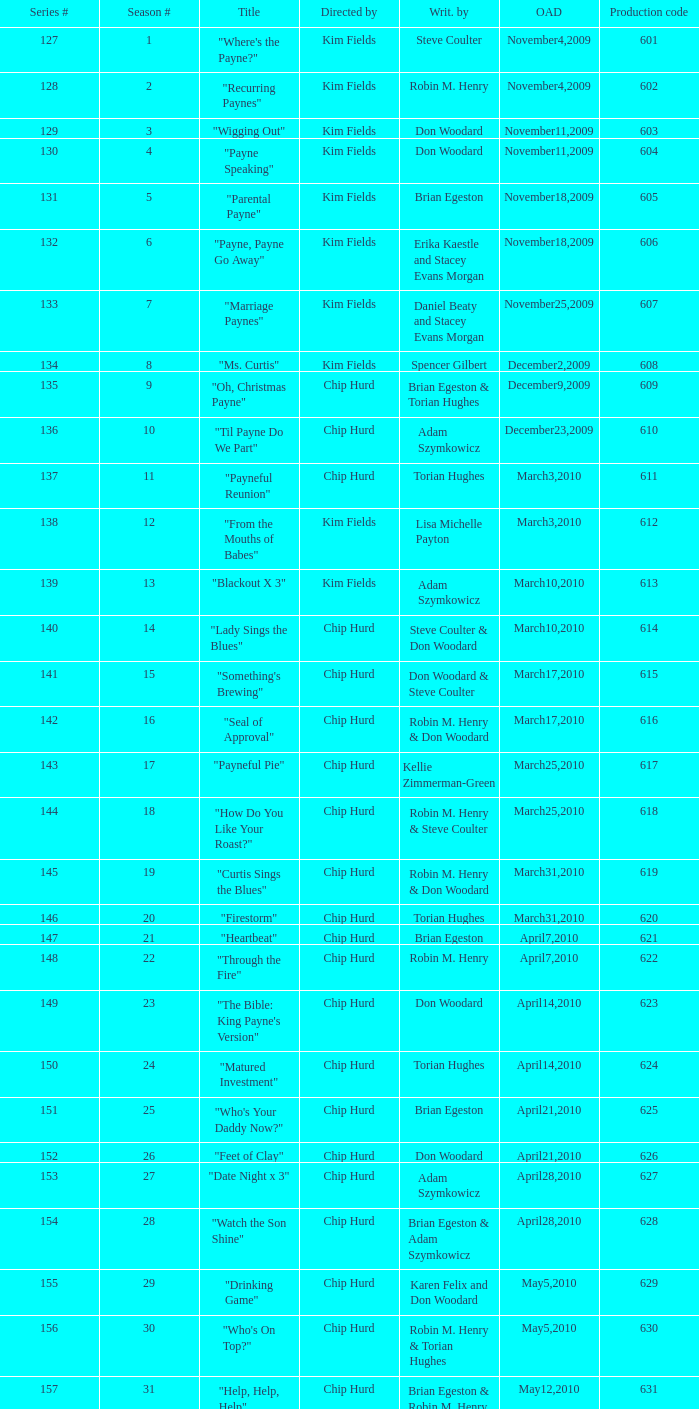What is the original air dates for the title "firestorm"? March31,2010. 